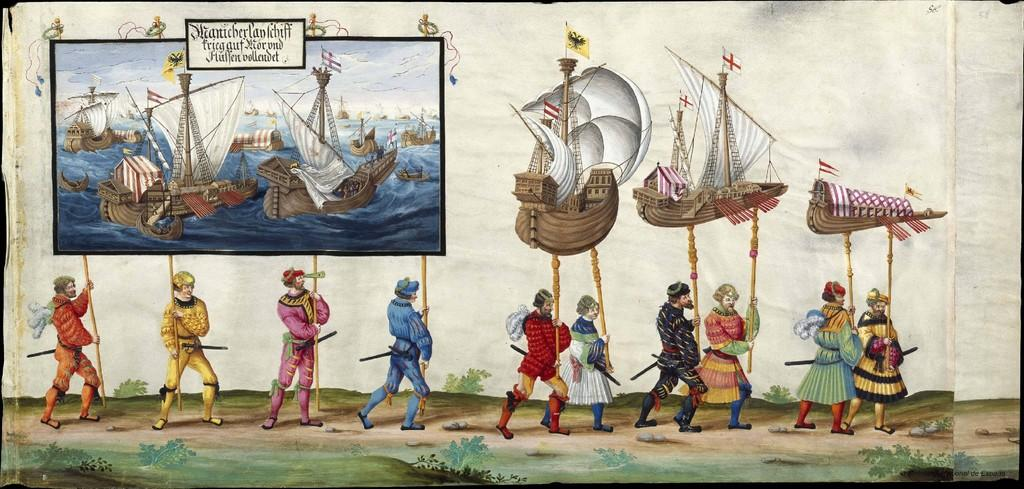What type of artwork is depicted in the image? The image is a painting. What are the people in the painting holding? The people are holding sticks with objects in the painting. What are the people doing in the painting? The people are walking through a walkway in the painting. What can be seen at the bottom of the painting? There are plants and stones at the bottom of the painting. Where is the nearest library to the people in the painting? There is no information about a library or its location in the painting. --- Facts: 1. There is a car in the image. 2. The car is parked on the street. 3. There are buildings in the background. 4. The sky is visible in the image. 5. There are trees on the side of the street. Absurd Topics: parade, ocean, volcano Conversation: What is the main subject of the image? The main subject of the image is a car. Where is the car located in the image? The car is parked on the street in the image. What can be seen in the background of the image? There are buildings in the background of the image. What is visible at the top of the image? The sky is visible in the image. What type of vegetation is present on the side of the street? There are trees on the side of the street in the image. Reasoning: Let's think step by step in order to produce the conversation. We start by identifying the main subject of the image, which is the car. Then, we describe the location of the car, noting that it is parked on the street. Next, we mention the background elements, including the buildings and sky. Finally, we describe the vegetation present on the side of the street, which are trees. Absurd Question/Answer: Can you see the ocean in the background of the image? No, the ocean is not visible in the image; there are only buildings and the sky in the background. --- Facts: 1. There is a person sitting on a bench in the image. 2. The person is reading a book. 3. There is a tree behind the bench. 4. The ground is visible in the image. 5. There is a fence in the background. Absurd Topics: parrot, sandcastle, roller coaster Conversation: What is the person in the image doing? The person is sitting on a bench and reading a book in the image. What can be seen behind the bench? There is a tree behind the bench in the image. What is visible at the bottom of the image? The ground is visible in the image. What is present in the background of the image? There is a fence in the background of the image. Reasoning: Let's think step by step in order to produce 